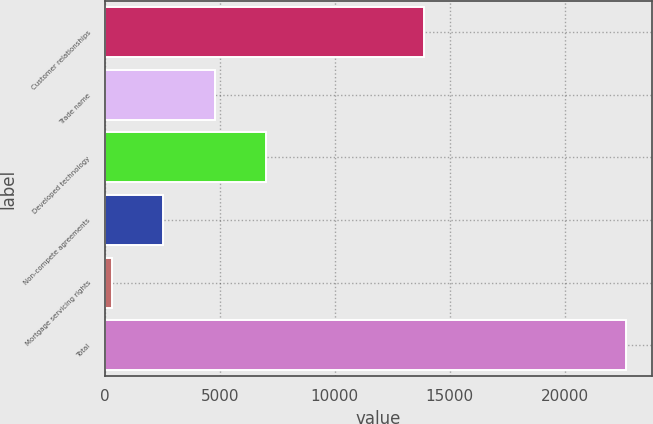Convert chart to OTSL. <chart><loc_0><loc_0><loc_500><loc_500><bar_chart><fcel>Customer relationships<fcel>Trade name<fcel>Developed technology<fcel>Non-compete agreements<fcel>Mortgage servicing rights<fcel>Total<nl><fcel>13875<fcel>4775<fcel>7012.5<fcel>2537.5<fcel>300<fcel>22675<nl></chart> 